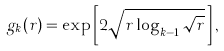Convert formula to latex. <formula><loc_0><loc_0><loc_500><loc_500>g _ { k } ( r ) = \exp \left [ 2 \sqrt { r \log _ { k - 1 } \sqrt { r } } \, \right ] ,</formula> 